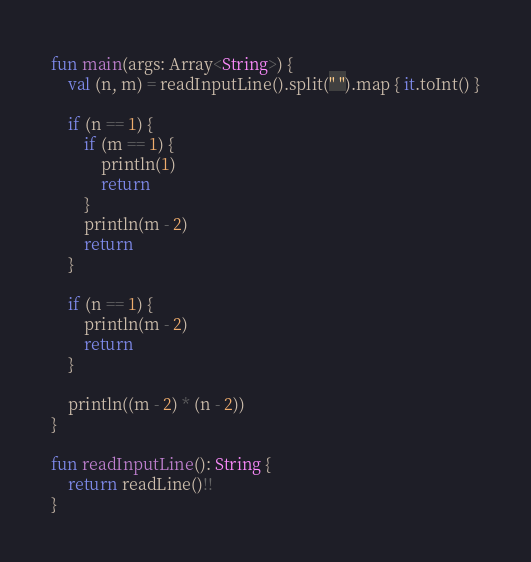<code> <loc_0><loc_0><loc_500><loc_500><_Kotlin_>fun main(args: Array<String>) {
    val (n, m) = readInputLine().split(" ").map { it.toInt() }
    
    if (n == 1) {
        if (m == 1) {
            println(1)
            return
        }
        println(m - 2)
        return
    }

    if (n == 1) {
        println(m - 2)
        return
    }

    println((m - 2) * (n - 2))
}

fun readInputLine(): String {
    return readLine()!!
}
</code> 